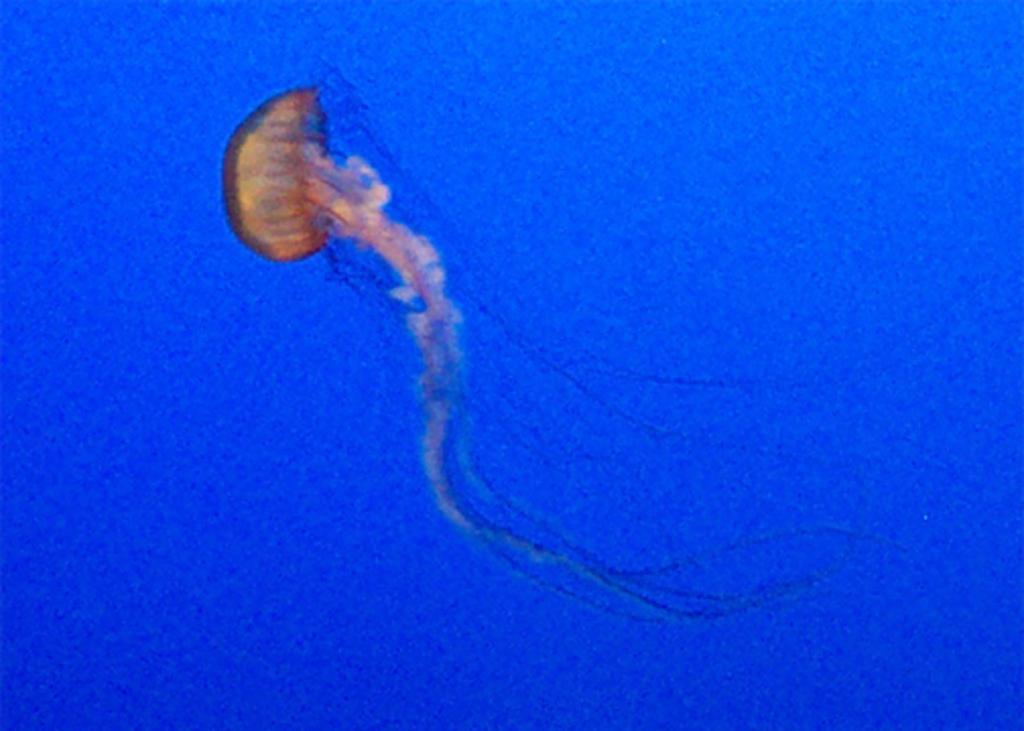Could you give a brief overview of what you see in this image? This image is taken in the sea. In the middle of the image there is a jellyfish in the water. 